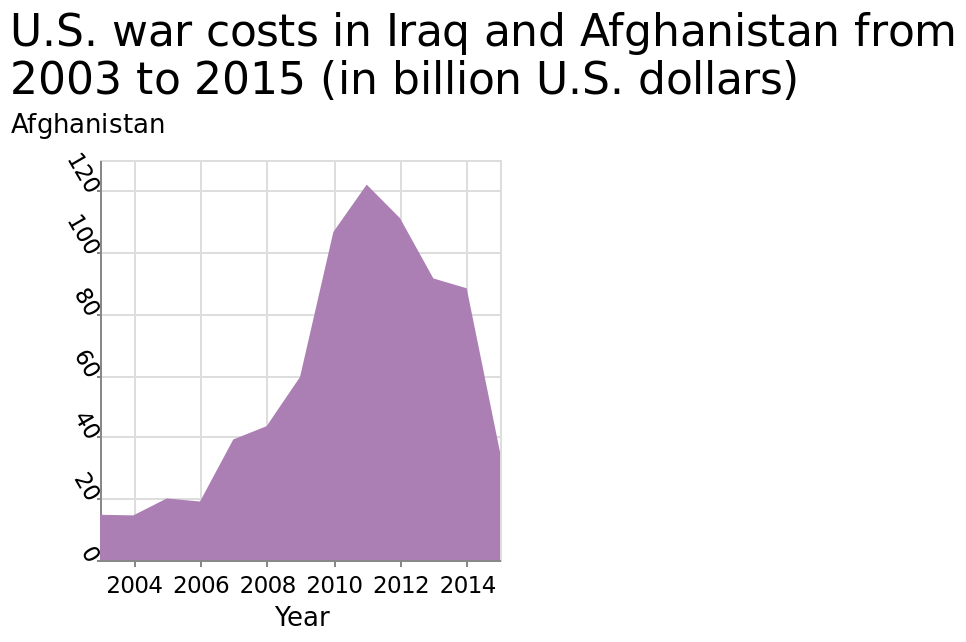<image>
Can you provide more details about the rate of decline over the years? Unfortunately, the description does not mention specific details about the rate of decline over the years. What is shown on the x-axis of the area plot?  The x-axis of the area plot represents the years from 2004 to 2014. please enumerates aspects of the construction of the chart Here a is a area plot labeled U.S. war costs in Iraq and Afghanistan from 2003 to 2015 (in billion U.S. dollars). Afghanistan is shown along the y-axis. On the x-axis, Year is measured along a linear scale from 2004 to 2014. 